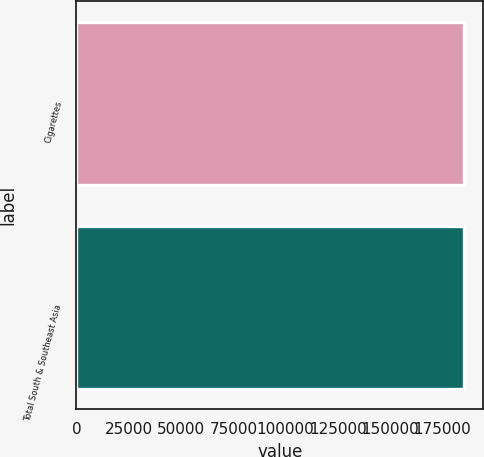Convert chart to OTSL. <chart><loc_0><loc_0><loc_500><loc_500><bar_chart><fcel>Cigarettes<fcel>Total South & Southeast Asia<nl><fcel>185279<fcel>185279<nl></chart> 